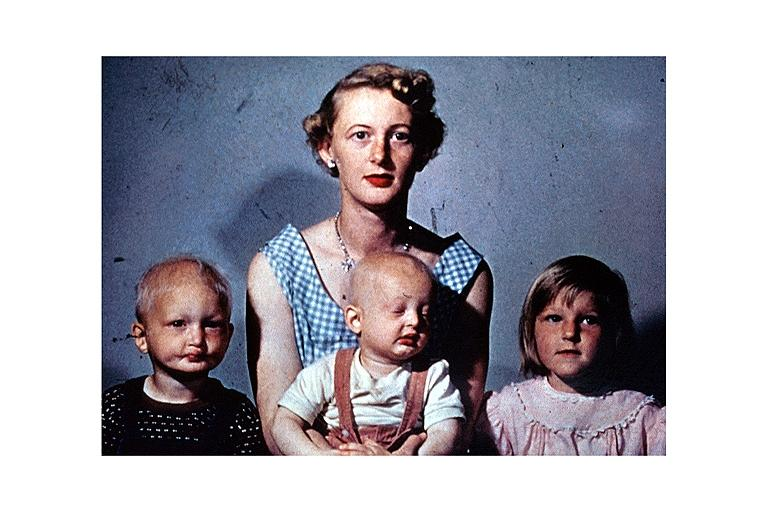s cervical carcinoma present?
Answer the question using a single word or phrase. No 